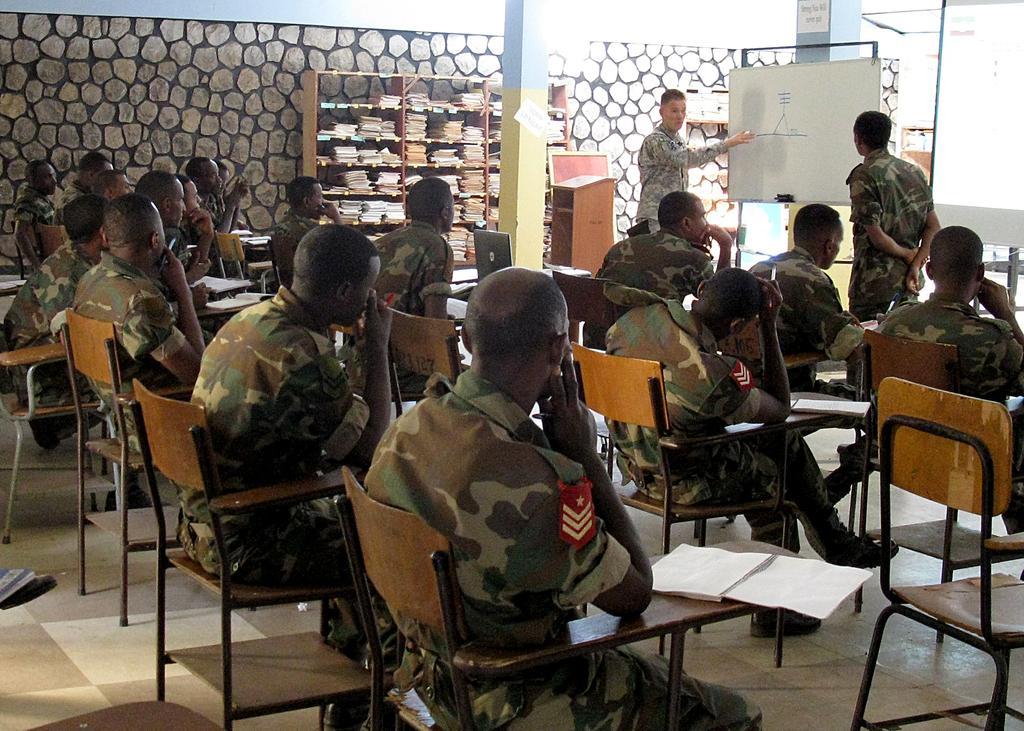Describe this image in one or two sentences. In this picture there are group of people those who are sitting on the chair in a row and there is a book shelf at the center of the image and there is a person who is standing at the right side of the image near a board he is explaining something to the people those who are sitting at the left side of the image, it seems to be a defence meeting. 